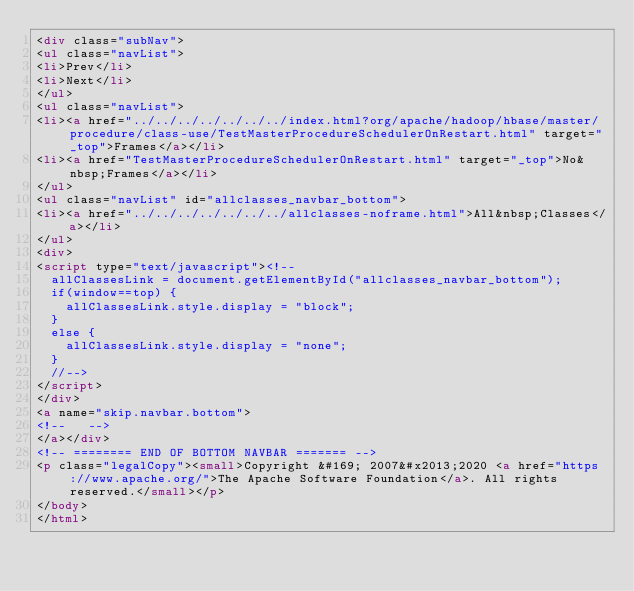<code> <loc_0><loc_0><loc_500><loc_500><_HTML_><div class="subNav">
<ul class="navList">
<li>Prev</li>
<li>Next</li>
</ul>
<ul class="navList">
<li><a href="../../../../../../../index.html?org/apache/hadoop/hbase/master/procedure/class-use/TestMasterProcedureSchedulerOnRestart.html" target="_top">Frames</a></li>
<li><a href="TestMasterProcedureSchedulerOnRestart.html" target="_top">No&nbsp;Frames</a></li>
</ul>
<ul class="navList" id="allclasses_navbar_bottom">
<li><a href="../../../../../../../allclasses-noframe.html">All&nbsp;Classes</a></li>
</ul>
<div>
<script type="text/javascript"><!--
  allClassesLink = document.getElementById("allclasses_navbar_bottom");
  if(window==top) {
    allClassesLink.style.display = "block";
  }
  else {
    allClassesLink.style.display = "none";
  }
  //-->
</script>
</div>
<a name="skip.navbar.bottom">
<!--   -->
</a></div>
<!-- ======== END OF BOTTOM NAVBAR ======= -->
<p class="legalCopy"><small>Copyright &#169; 2007&#x2013;2020 <a href="https://www.apache.org/">The Apache Software Foundation</a>. All rights reserved.</small></p>
</body>
</html>
</code> 